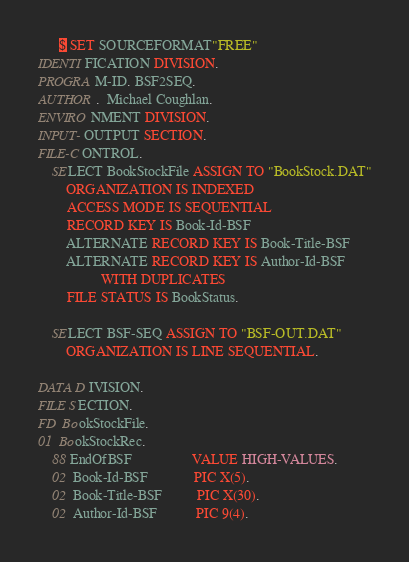Convert code to text. <code><loc_0><loc_0><loc_500><loc_500><_COBOL_>      $ SET SOURCEFORMAT"FREE"
IDENTIFICATION DIVISION.
PROGRAM-ID. BSF2SEQ.
AUTHOR.  Michael Coughlan.
ENVIRONMENT DIVISION.
INPUT-OUTPUT SECTION.
FILE-CONTROL.
    SELECT BookStockFile ASSIGN TO "BookStock.DAT"
        ORGANIZATION IS INDEXED
        ACCESS MODE IS SEQUENTIAL
        RECORD KEY IS Book-Id-BSF
        ALTERNATE RECORD KEY IS Book-Title-BSF
        ALTERNATE RECORD KEY IS Author-Id-BSF
                  WITH DUPLICATES
        FILE STATUS IS BookStatus.

    SELECT BSF-SEQ ASSIGN TO "BSF-OUT.DAT"
        ORGANIZATION IS LINE SEQUENTIAL.

DATA DIVISION.
FILE SECTION.
FD  BookStockFile.
01  BookStockRec.
    88 EndOfBSF                 VALUE HIGH-VALUES.
    02  Book-Id-BSF             PIC X(5).
    02  Book-Title-BSF          PIC X(30).
    02  Author-Id-BSF           PIC 9(4).</code> 